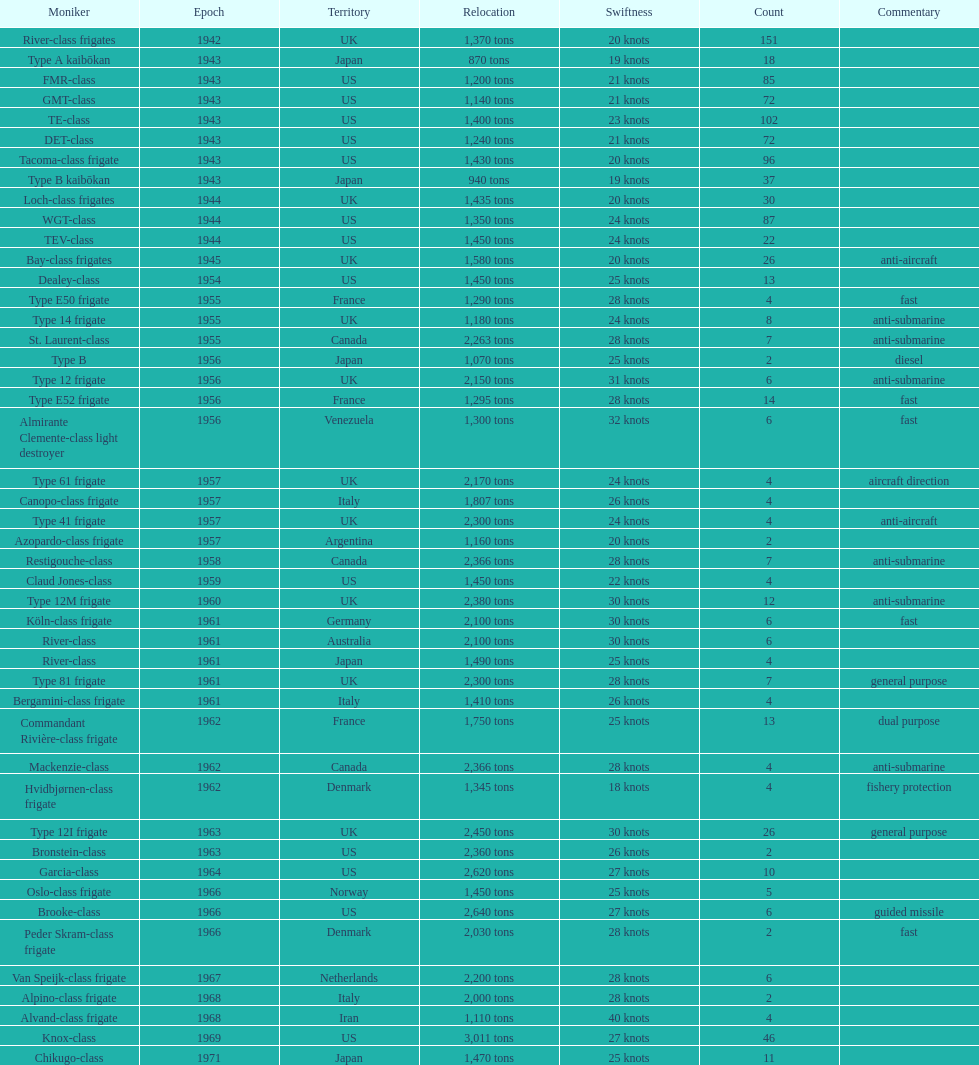How many tons of displacement does type b have? 940 tons. 